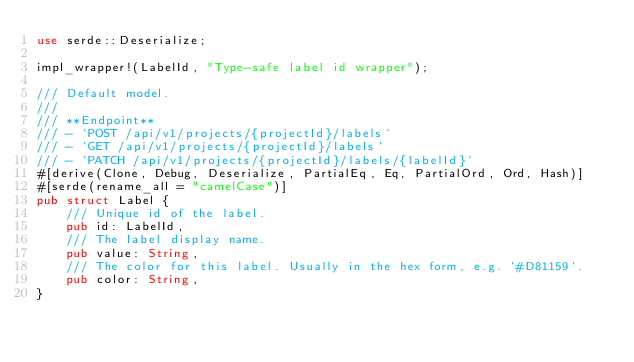<code> <loc_0><loc_0><loc_500><loc_500><_Rust_>use serde::Deserialize;

impl_wrapper!(LabelId, "Type-safe label id wrapper");

/// Default model.
///
/// **Endpoint**
/// - `POST /api/v1/projects/{projectId}/labels`
/// - `GET /api/v1/projects/{projectId}/labels`
/// - `PATCH /api/v1/projects/{projectId}/labels/{labelId}`
#[derive(Clone, Debug, Deserialize, PartialEq, Eq, PartialOrd, Ord, Hash)]
#[serde(rename_all = "camelCase")]
pub struct Label {
    /// Unique id of the label.
    pub id: LabelId,
    /// The label display name.
    pub value: String,
    /// The color for this label. Usually in the hex form, e.g. `#D81159`.
    pub color: String,
}
</code> 